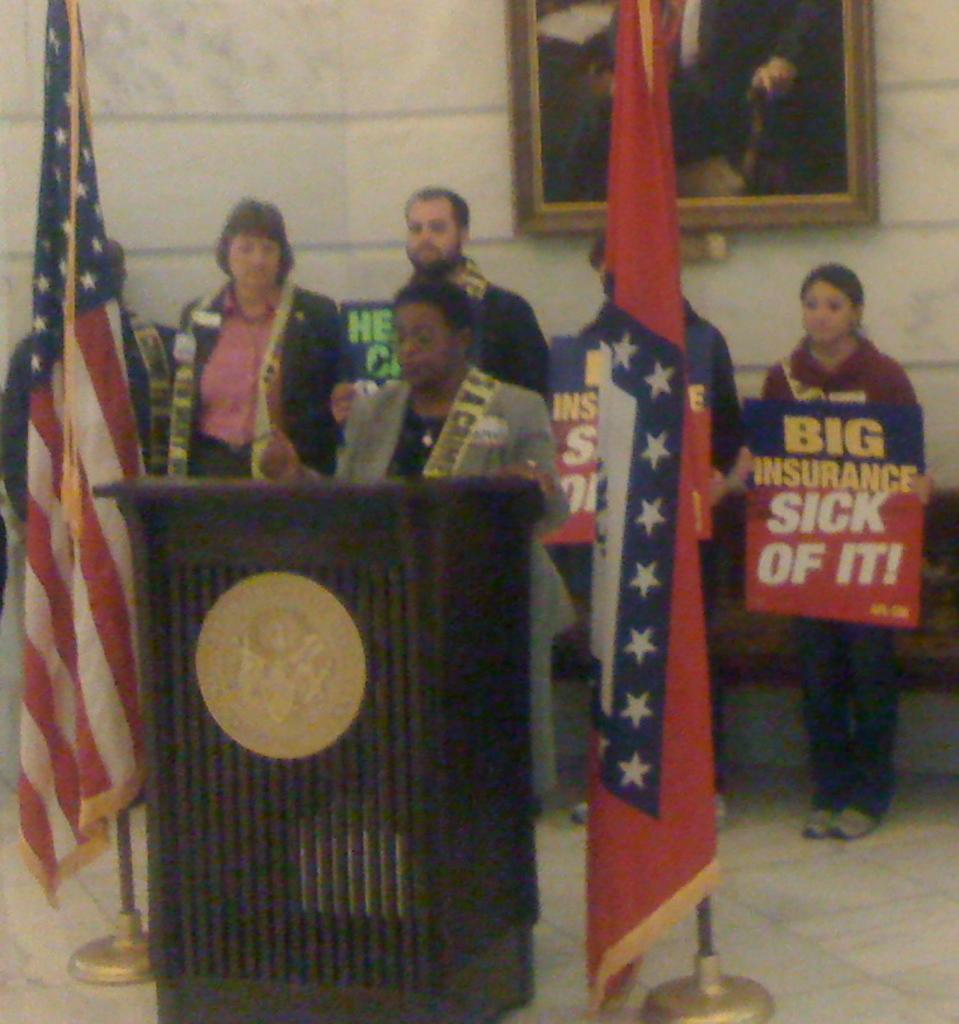What is the sign holder sick of?
Provide a succinct answer. Big insurance. 